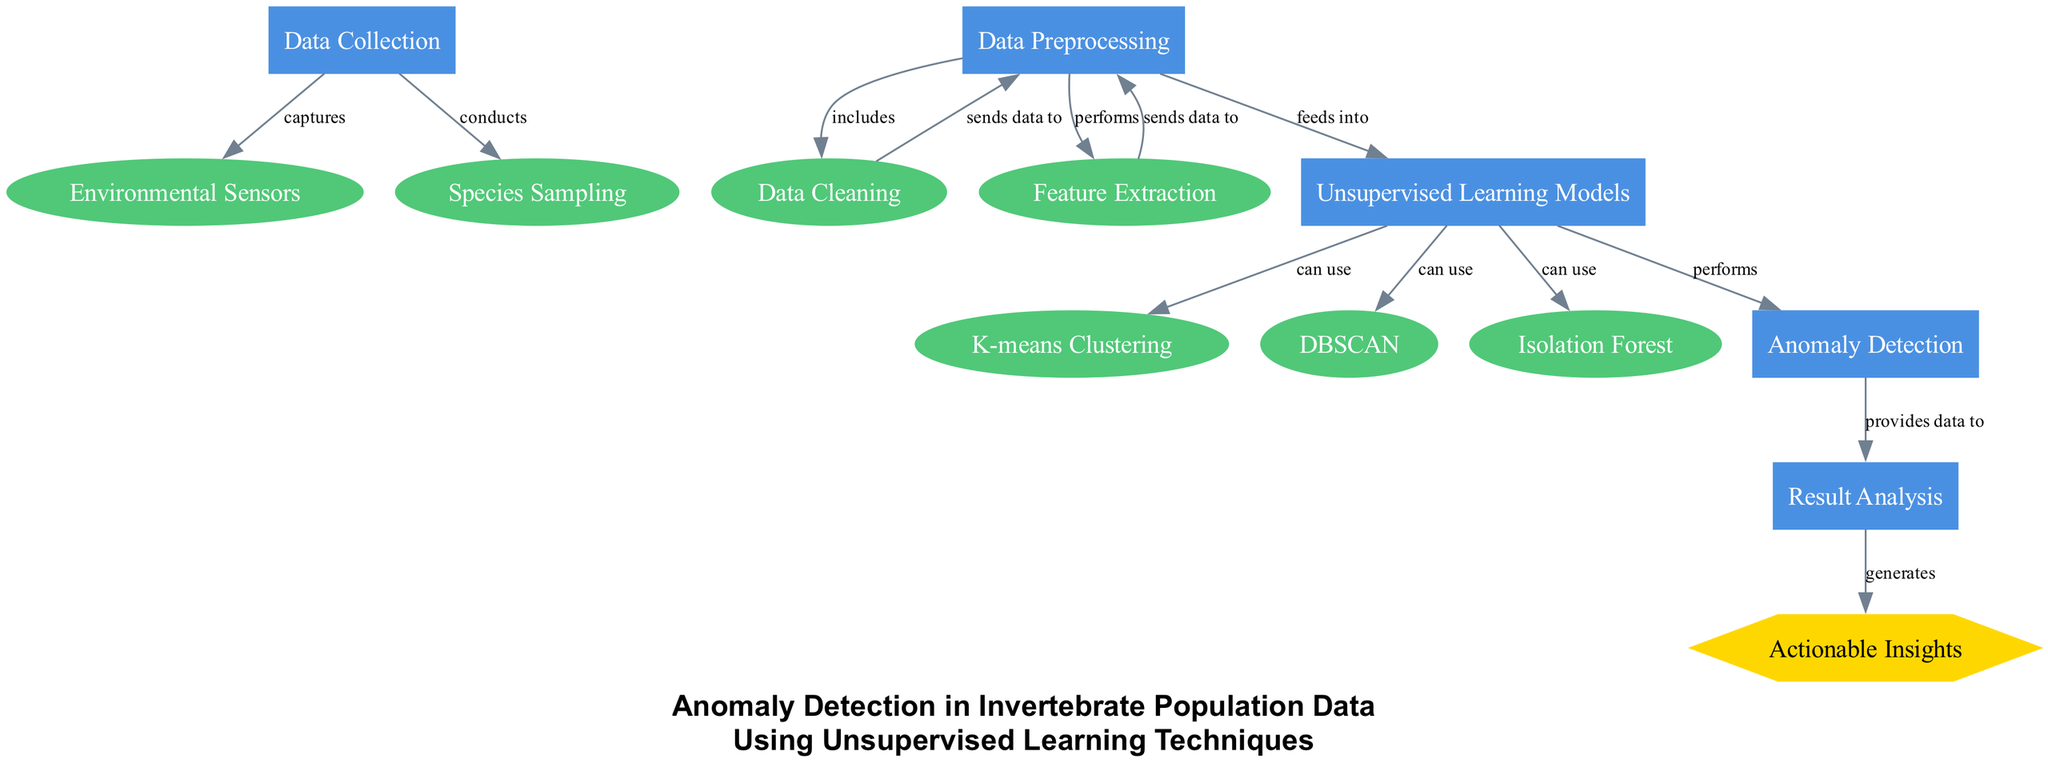What is the first step in the anomaly detection process? The first step as indicated in the diagram is "Data Collection."
Answer: Data Collection How many unsupervised learning models are represented in the diagram? There are three unsupervised learning models shown: K-means Clustering, DBSCAN, and Isolation Forest.
Answer: Three What type of relationship exists between "Data Preprocessing" and "Data Cleaning"? "Data Preprocessing" includes "Data Cleaning," which indicates a hierarchical or processual relationship.
Answer: Includes What processes are performed after "Data Preprocessing"? Following "Data Preprocessing," the processes are "Data Cleaning" and "Feature Extraction," which both send their data to "Data Preprocessing."
Answer: Data Cleaning and Feature Extraction Which node generates actionable insights? "Result Analysis" generates actionable insights as it is connected to "Actionable Insights" by the edge labeled "generates."
Answer: Result Analysis Which of the unsupervised learning models is the last step of the anomaly detection process? The last step of the anomaly detection process that uses an unsupervised learning model is "Anomaly Detection."
Answer: Anomaly Detection What node feeds into "Unsupervised Learning Models"? "Data Preprocessing" feeds into "Unsupervised Learning Models," indicating it provides input for further analysis.
Answer: Data Preprocessing How many edges connect to the "K-means Clustering" model? There is one edge that connects to the "K-means Clustering" model from "Unsupervised Learning Models," indicating an available route for processing.
Answer: One What does the "Environmental Sensors" node capture? The "Environmental Sensors" node captures data, as described by the relationship directed towards the "Data Collection."
Answer: Data 